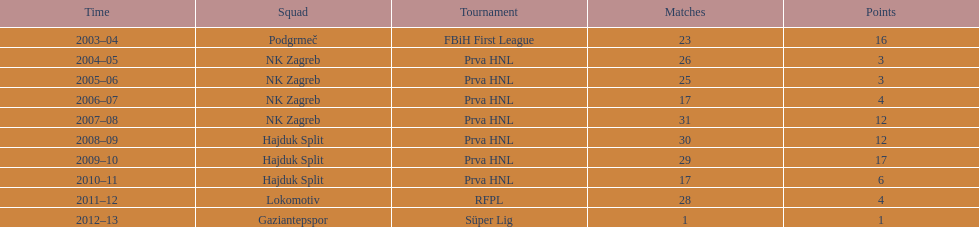Which club names had over 15 goals scored in one season? Podgrmeč, Hajduk Split. 